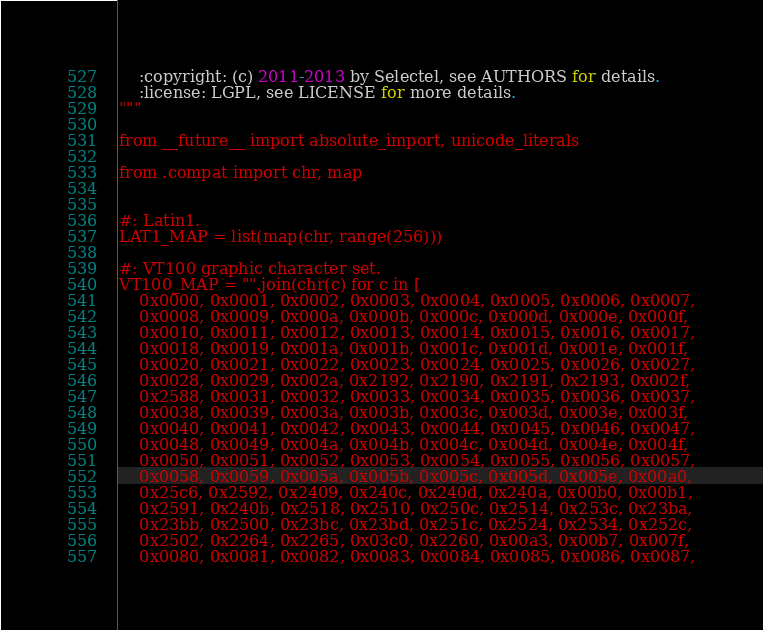<code> <loc_0><loc_0><loc_500><loc_500><_Python_>
    :copyright: (c) 2011-2013 by Selectel, see AUTHORS for details.
    :license: LGPL, see LICENSE for more details.
"""

from __future__ import absolute_import, unicode_literals

from .compat import chr, map


#: Latin1.
LAT1_MAP = list(map(chr, range(256)))

#: VT100 graphic character set.
VT100_MAP = "".join(chr(c) for c in [
    0x0000, 0x0001, 0x0002, 0x0003, 0x0004, 0x0005, 0x0006, 0x0007,
    0x0008, 0x0009, 0x000a, 0x000b, 0x000c, 0x000d, 0x000e, 0x000f,
    0x0010, 0x0011, 0x0012, 0x0013, 0x0014, 0x0015, 0x0016, 0x0017,
    0x0018, 0x0019, 0x001a, 0x001b, 0x001c, 0x001d, 0x001e, 0x001f,
    0x0020, 0x0021, 0x0022, 0x0023, 0x0024, 0x0025, 0x0026, 0x0027,
    0x0028, 0x0029, 0x002a, 0x2192, 0x2190, 0x2191, 0x2193, 0x002f,
    0x2588, 0x0031, 0x0032, 0x0033, 0x0034, 0x0035, 0x0036, 0x0037,
    0x0038, 0x0039, 0x003a, 0x003b, 0x003c, 0x003d, 0x003e, 0x003f,
    0x0040, 0x0041, 0x0042, 0x0043, 0x0044, 0x0045, 0x0046, 0x0047,
    0x0048, 0x0049, 0x004a, 0x004b, 0x004c, 0x004d, 0x004e, 0x004f,
    0x0050, 0x0051, 0x0052, 0x0053, 0x0054, 0x0055, 0x0056, 0x0057,
    0x0058, 0x0059, 0x005a, 0x005b, 0x005c, 0x005d, 0x005e, 0x00a0,
    0x25c6, 0x2592, 0x2409, 0x240c, 0x240d, 0x240a, 0x00b0, 0x00b1,
    0x2591, 0x240b, 0x2518, 0x2510, 0x250c, 0x2514, 0x253c, 0x23ba,
    0x23bb, 0x2500, 0x23bc, 0x23bd, 0x251c, 0x2524, 0x2534, 0x252c,
    0x2502, 0x2264, 0x2265, 0x03c0, 0x2260, 0x00a3, 0x00b7, 0x007f,
    0x0080, 0x0081, 0x0082, 0x0083, 0x0084, 0x0085, 0x0086, 0x0087,</code> 